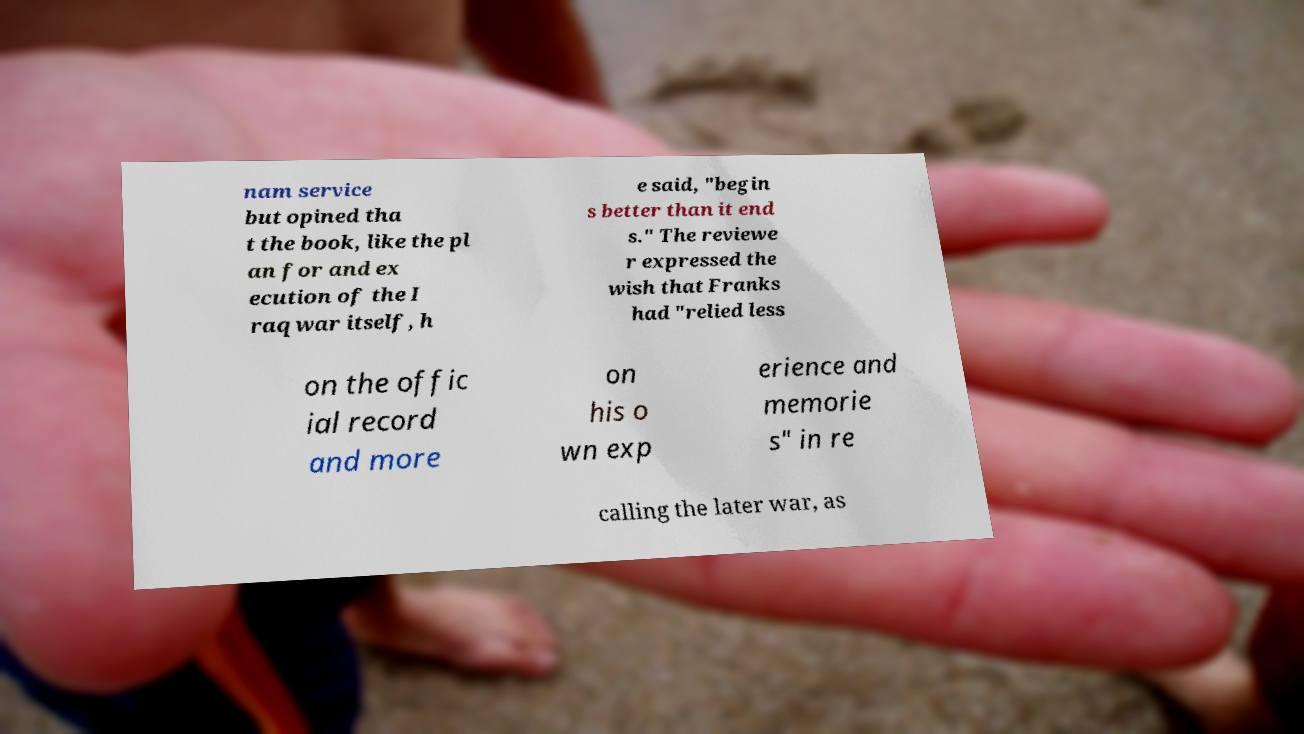There's text embedded in this image that I need extracted. Can you transcribe it verbatim? nam service but opined tha t the book, like the pl an for and ex ecution of the I raq war itself, h e said, "begin s better than it end s." The reviewe r expressed the wish that Franks had "relied less on the offic ial record and more on his o wn exp erience and memorie s" in re calling the later war, as 